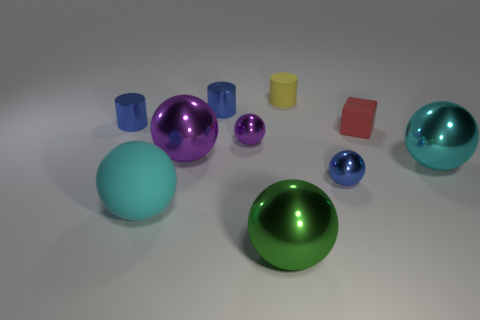Subtract all yellow cylinders. How many cylinders are left? 2 Subtract all tiny balls. How many balls are left? 4 Subtract 0 green cubes. How many objects are left? 10 Subtract all cylinders. How many objects are left? 7 Subtract 2 spheres. How many spheres are left? 4 Subtract all brown spheres. Subtract all green blocks. How many spheres are left? 6 Subtract all yellow balls. How many yellow cubes are left? 0 Subtract all blue metallic spheres. Subtract all blue things. How many objects are left? 6 Add 6 blue shiny objects. How many blue shiny objects are left? 9 Add 3 cyan metal things. How many cyan metal things exist? 4 